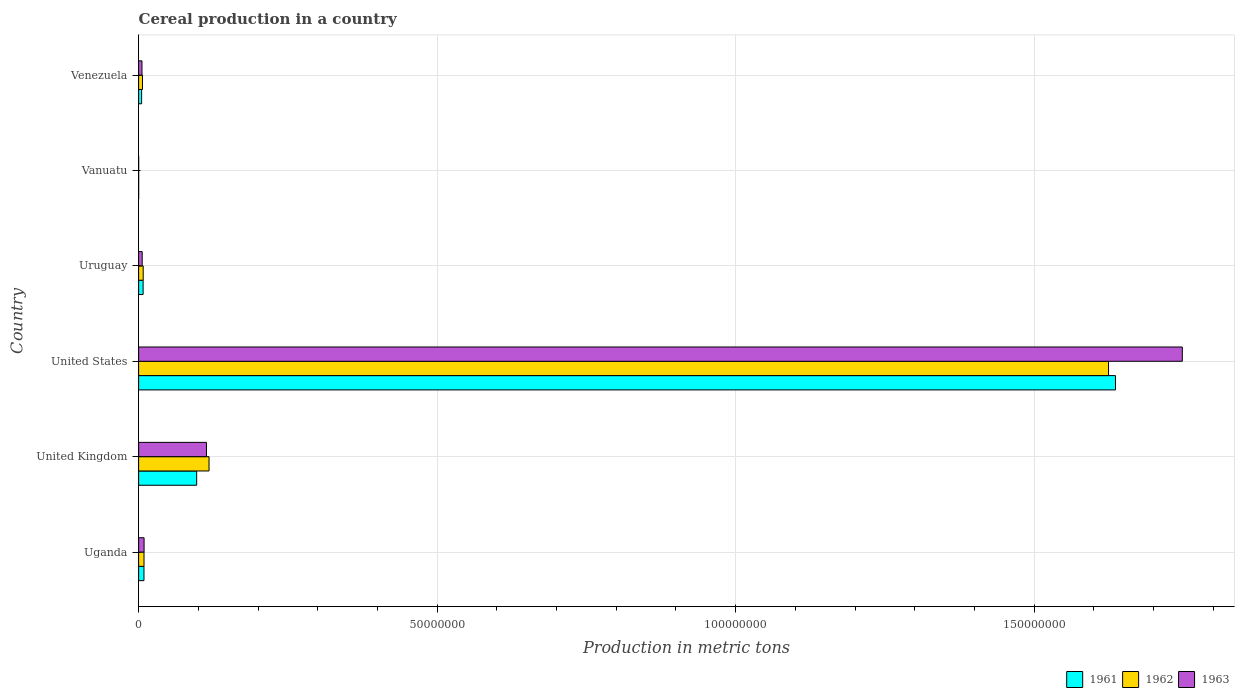How many different coloured bars are there?
Provide a short and direct response. 3. How many bars are there on the 5th tick from the top?
Offer a very short reply. 3. What is the label of the 3rd group of bars from the top?
Offer a terse response. Uruguay. What is the total cereal production in 1963 in Venezuela?
Offer a very short reply. 5.62e+05. Across all countries, what is the maximum total cereal production in 1962?
Your answer should be very brief. 1.62e+08. Across all countries, what is the minimum total cereal production in 1961?
Your response must be concise. 350. In which country was the total cereal production in 1961 maximum?
Keep it short and to the point. United States. In which country was the total cereal production in 1963 minimum?
Provide a succinct answer. Vanuatu. What is the total total cereal production in 1962 in the graph?
Ensure brevity in your answer.  1.77e+08. What is the difference between the total cereal production in 1961 in United States and that in Vanuatu?
Offer a terse response. 1.64e+08. What is the difference between the total cereal production in 1963 in Venezuela and the total cereal production in 1961 in United States?
Provide a succinct answer. -1.63e+08. What is the average total cereal production in 1961 per country?
Offer a very short reply. 2.92e+07. What is the difference between the total cereal production in 1962 and total cereal production in 1961 in Uruguay?
Keep it short and to the point. 1.37e+04. What is the ratio of the total cereal production in 1961 in Uganda to that in United States?
Your answer should be compact. 0.01. Is the total cereal production in 1963 in United Kingdom less than that in United States?
Your answer should be very brief. Yes. Is the difference between the total cereal production in 1962 in United States and Uruguay greater than the difference between the total cereal production in 1961 in United States and Uruguay?
Offer a terse response. No. What is the difference between the highest and the second highest total cereal production in 1962?
Provide a succinct answer. 1.51e+08. What is the difference between the highest and the lowest total cereal production in 1962?
Keep it short and to the point. 1.62e+08. In how many countries, is the total cereal production in 1963 greater than the average total cereal production in 1963 taken over all countries?
Make the answer very short. 1. Is the sum of the total cereal production in 1962 in United States and Uruguay greater than the maximum total cereal production in 1961 across all countries?
Provide a short and direct response. No. What does the 3rd bar from the top in Vanuatu represents?
Provide a succinct answer. 1961. Is it the case that in every country, the sum of the total cereal production in 1961 and total cereal production in 1963 is greater than the total cereal production in 1962?
Your answer should be very brief. Yes. How many countries are there in the graph?
Ensure brevity in your answer.  6. Where does the legend appear in the graph?
Offer a very short reply. Bottom right. How are the legend labels stacked?
Make the answer very short. Horizontal. What is the title of the graph?
Your response must be concise. Cereal production in a country. Does "1983" appear as one of the legend labels in the graph?
Provide a succinct answer. No. What is the label or title of the X-axis?
Provide a short and direct response. Production in metric tons. What is the Production in metric tons in 1961 in Uganda?
Your answer should be compact. 8.95e+05. What is the Production in metric tons of 1962 in Uganda?
Ensure brevity in your answer.  9.02e+05. What is the Production in metric tons of 1963 in Uganda?
Offer a terse response. 9.13e+05. What is the Production in metric tons of 1961 in United Kingdom?
Your answer should be compact. 9.72e+06. What is the Production in metric tons of 1962 in United Kingdom?
Offer a terse response. 1.18e+07. What is the Production in metric tons in 1963 in United Kingdom?
Your answer should be compact. 1.14e+07. What is the Production in metric tons of 1961 in United States?
Make the answer very short. 1.64e+08. What is the Production in metric tons in 1962 in United States?
Give a very brief answer. 1.62e+08. What is the Production in metric tons of 1963 in United States?
Ensure brevity in your answer.  1.75e+08. What is the Production in metric tons in 1961 in Uruguay?
Your answer should be compact. 7.51e+05. What is the Production in metric tons in 1962 in Uruguay?
Make the answer very short. 7.65e+05. What is the Production in metric tons in 1963 in Uruguay?
Provide a succinct answer. 5.97e+05. What is the Production in metric tons of 1961 in Vanuatu?
Give a very brief answer. 350. What is the Production in metric tons of 1962 in Vanuatu?
Make the answer very short. 350. What is the Production in metric tons in 1963 in Vanuatu?
Offer a terse response. 350. What is the Production in metric tons of 1961 in Venezuela?
Your response must be concise. 5.01e+05. What is the Production in metric tons of 1962 in Venezuela?
Provide a short and direct response. 6.44e+05. What is the Production in metric tons in 1963 in Venezuela?
Offer a terse response. 5.62e+05. Across all countries, what is the maximum Production in metric tons of 1961?
Your answer should be compact. 1.64e+08. Across all countries, what is the maximum Production in metric tons of 1962?
Keep it short and to the point. 1.62e+08. Across all countries, what is the maximum Production in metric tons of 1963?
Ensure brevity in your answer.  1.75e+08. Across all countries, what is the minimum Production in metric tons in 1961?
Your response must be concise. 350. Across all countries, what is the minimum Production in metric tons of 1962?
Ensure brevity in your answer.  350. Across all countries, what is the minimum Production in metric tons in 1963?
Offer a terse response. 350. What is the total Production in metric tons in 1961 in the graph?
Give a very brief answer. 1.75e+08. What is the total Production in metric tons of 1962 in the graph?
Your response must be concise. 1.77e+08. What is the total Production in metric tons of 1963 in the graph?
Offer a terse response. 1.88e+08. What is the difference between the Production in metric tons in 1961 in Uganda and that in United Kingdom?
Your answer should be very brief. -8.83e+06. What is the difference between the Production in metric tons in 1962 in Uganda and that in United Kingdom?
Your response must be concise. -1.09e+07. What is the difference between the Production in metric tons in 1963 in Uganda and that in United Kingdom?
Keep it short and to the point. -1.05e+07. What is the difference between the Production in metric tons of 1961 in Uganda and that in United States?
Your response must be concise. -1.63e+08. What is the difference between the Production in metric tons in 1962 in Uganda and that in United States?
Offer a very short reply. -1.62e+08. What is the difference between the Production in metric tons of 1963 in Uganda and that in United States?
Ensure brevity in your answer.  -1.74e+08. What is the difference between the Production in metric tons of 1961 in Uganda and that in Uruguay?
Provide a short and direct response. 1.44e+05. What is the difference between the Production in metric tons of 1962 in Uganda and that in Uruguay?
Offer a terse response. 1.37e+05. What is the difference between the Production in metric tons in 1963 in Uganda and that in Uruguay?
Make the answer very short. 3.16e+05. What is the difference between the Production in metric tons of 1961 in Uganda and that in Vanuatu?
Make the answer very short. 8.95e+05. What is the difference between the Production in metric tons of 1962 in Uganda and that in Vanuatu?
Your response must be concise. 9.02e+05. What is the difference between the Production in metric tons in 1963 in Uganda and that in Vanuatu?
Your answer should be compact. 9.12e+05. What is the difference between the Production in metric tons in 1961 in Uganda and that in Venezuela?
Offer a very short reply. 3.94e+05. What is the difference between the Production in metric tons of 1962 in Uganda and that in Venezuela?
Keep it short and to the point. 2.58e+05. What is the difference between the Production in metric tons of 1963 in Uganda and that in Venezuela?
Ensure brevity in your answer.  3.50e+05. What is the difference between the Production in metric tons of 1961 in United Kingdom and that in United States?
Provide a short and direct response. -1.54e+08. What is the difference between the Production in metric tons in 1962 in United Kingdom and that in United States?
Provide a succinct answer. -1.51e+08. What is the difference between the Production in metric tons of 1963 in United Kingdom and that in United States?
Make the answer very short. -1.63e+08. What is the difference between the Production in metric tons in 1961 in United Kingdom and that in Uruguay?
Provide a short and direct response. 8.97e+06. What is the difference between the Production in metric tons in 1962 in United Kingdom and that in Uruguay?
Provide a short and direct response. 1.10e+07. What is the difference between the Production in metric tons of 1963 in United Kingdom and that in Uruguay?
Provide a short and direct response. 1.08e+07. What is the difference between the Production in metric tons of 1961 in United Kingdom and that in Vanuatu?
Make the answer very short. 9.72e+06. What is the difference between the Production in metric tons of 1962 in United Kingdom and that in Vanuatu?
Give a very brief answer. 1.18e+07. What is the difference between the Production in metric tons in 1963 in United Kingdom and that in Vanuatu?
Offer a terse response. 1.14e+07. What is the difference between the Production in metric tons of 1961 in United Kingdom and that in Venezuela?
Give a very brief answer. 9.22e+06. What is the difference between the Production in metric tons in 1962 in United Kingdom and that in Venezuela?
Ensure brevity in your answer.  1.11e+07. What is the difference between the Production in metric tons of 1963 in United Kingdom and that in Venezuela?
Provide a succinct answer. 1.08e+07. What is the difference between the Production in metric tons of 1961 in United States and that in Uruguay?
Provide a succinct answer. 1.63e+08. What is the difference between the Production in metric tons of 1962 in United States and that in Uruguay?
Provide a succinct answer. 1.62e+08. What is the difference between the Production in metric tons of 1963 in United States and that in Uruguay?
Give a very brief answer. 1.74e+08. What is the difference between the Production in metric tons in 1961 in United States and that in Vanuatu?
Provide a short and direct response. 1.64e+08. What is the difference between the Production in metric tons of 1962 in United States and that in Vanuatu?
Provide a succinct answer. 1.62e+08. What is the difference between the Production in metric tons in 1963 in United States and that in Vanuatu?
Your response must be concise. 1.75e+08. What is the difference between the Production in metric tons of 1961 in United States and that in Venezuela?
Provide a short and direct response. 1.63e+08. What is the difference between the Production in metric tons in 1962 in United States and that in Venezuela?
Make the answer very short. 1.62e+08. What is the difference between the Production in metric tons in 1963 in United States and that in Venezuela?
Offer a terse response. 1.74e+08. What is the difference between the Production in metric tons in 1961 in Uruguay and that in Vanuatu?
Ensure brevity in your answer.  7.51e+05. What is the difference between the Production in metric tons in 1962 in Uruguay and that in Vanuatu?
Offer a terse response. 7.64e+05. What is the difference between the Production in metric tons of 1963 in Uruguay and that in Vanuatu?
Ensure brevity in your answer.  5.96e+05. What is the difference between the Production in metric tons of 1961 in Uruguay and that in Venezuela?
Offer a terse response. 2.50e+05. What is the difference between the Production in metric tons in 1962 in Uruguay and that in Venezuela?
Your response must be concise. 1.20e+05. What is the difference between the Production in metric tons in 1963 in Uruguay and that in Venezuela?
Make the answer very short. 3.44e+04. What is the difference between the Production in metric tons in 1961 in Vanuatu and that in Venezuela?
Your answer should be compact. -5.01e+05. What is the difference between the Production in metric tons in 1962 in Vanuatu and that in Venezuela?
Make the answer very short. -6.44e+05. What is the difference between the Production in metric tons of 1963 in Vanuatu and that in Venezuela?
Offer a terse response. -5.62e+05. What is the difference between the Production in metric tons of 1961 in Uganda and the Production in metric tons of 1962 in United Kingdom?
Offer a very short reply. -1.09e+07. What is the difference between the Production in metric tons in 1961 in Uganda and the Production in metric tons in 1963 in United Kingdom?
Ensure brevity in your answer.  -1.05e+07. What is the difference between the Production in metric tons in 1962 in Uganda and the Production in metric tons in 1963 in United Kingdom?
Your answer should be compact. -1.05e+07. What is the difference between the Production in metric tons of 1961 in Uganda and the Production in metric tons of 1962 in United States?
Offer a terse response. -1.62e+08. What is the difference between the Production in metric tons of 1961 in Uganda and the Production in metric tons of 1963 in United States?
Your answer should be compact. -1.74e+08. What is the difference between the Production in metric tons in 1962 in Uganda and the Production in metric tons in 1963 in United States?
Offer a terse response. -1.74e+08. What is the difference between the Production in metric tons in 1961 in Uganda and the Production in metric tons in 1962 in Uruguay?
Your response must be concise. 1.31e+05. What is the difference between the Production in metric tons of 1961 in Uganda and the Production in metric tons of 1963 in Uruguay?
Offer a very short reply. 2.98e+05. What is the difference between the Production in metric tons in 1962 in Uganda and the Production in metric tons in 1963 in Uruguay?
Your answer should be compact. 3.05e+05. What is the difference between the Production in metric tons in 1961 in Uganda and the Production in metric tons in 1962 in Vanuatu?
Make the answer very short. 8.95e+05. What is the difference between the Production in metric tons in 1961 in Uganda and the Production in metric tons in 1963 in Vanuatu?
Your answer should be very brief. 8.95e+05. What is the difference between the Production in metric tons of 1962 in Uganda and the Production in metric tons of 1963 in Vanuatu?
Keep it short and to the point. 9.02e+05. What is the difference between the Production in metric tons in 1961 in Uganda and the Production in metric tons in 1962 in Venezuela?
Keep it short and to the point. 2.51e+05. What is the difference between the Production in metric tons in 1961 in Uganda and the Production in metric tons in 1963 in Venezuela?
Your response must be concise. 3.33e+05. What is the difference between the Production in metric tons in 1962 in Uganda and the Production in metric tons in 1963 in Venezuela?
Provide a short and direct response. 3.40e+05. What is the difference between the Production in metric tons in 1961 in United Kingdom and the Production in metric tons in 1962 in United States?
Give a very brief answer. -1.53e+08. What is the difference between the Production in metric tons in 1961 in United Kingdom and the Production in metric tons in 1963 in United States?
Provide a short and direct response. -1.65e+08. What is the difference between the Production in metric tons of 1962 in United Kingdom and the Production in metric tons of 1963 in United States?
Your response must be concise. -1.63e+08. What is the difference between the Production in metric tons of 1961 in United Kingdom and the Production in metric tons of 1962 in Uruguay?
Offer a terse response. 8.96e+06. What is the difference between the Production in metric tons of 1961 in United Kingdom and the Production in metric tons of 1963 in Uruguay?
Provide a short and direct response. 9.13e+06. What is the difference between the Production in metric tons in 1962 in United Kingdom and the Production in metric tons in 1963 in Uruguay?
Make the answer very short. 1.12e+07. What is the difference between the Production in metric tons in 1961 in United Kingdom and the Production in metric tons in 1962 in Vanuatu?
Make the answer very short. 9.72e+06. What is the difference between the Production in metric tons of 1961 in United Kingdom and the Production in metric tons of 1963 in Vanuatu?
Offer a very short reply. 9.72e+06. What is the difference between the Production in metric tons in 1962 in United Kingdom and the Production in metric tons in 1963 in Vanuatu?
Your answer should be compact. 1.18e+07. What is the difference between the Production in metric tons of 1961 in United Kingdom and the Production in metric tons of 1962 in Venezuela?
Provide a succinct answer. 9.08e+06. What is the difference between the Production in metric tons in 1961 in United Kingdom and the Production in metric tons in 1963 in Venezuela?
Make the answer very short. 9.16e+06. What is the difference between the Production in metric tons in 1962 in United Kingdom and the Production in metric tons in 1963 in Venezuela?
Keep it short and to the point. 1.12e+07. What is the difference between the Production in metric tons in 1961 in United States and the Production in metric tons in 1962 in Uruguay?
Your answer should be compact. 1.63e+08. What is the difference between the Production in metric tons of 1961 in United States and the Production in metric tons of 1963 in Uruguay?
Your response must be concise. 1.63e+08. What is the difference between the Production in metric tons of 1962 in United States and the Production in metric tons of 1963 in Uruguay?
Offer a very short reply. 1.62e+08. What is the difference between the Production in metric tons of 1961 in United States and the Production in metric tons of 1962 in Vanuatu?
Your response must be concise. 1.64e+08. What is the difference between the Production in metric tons in 1961 in United States and the Production in metric tons in 1963 in Vanuatu?
Ensure brevity in your answer.  1.64e+08. What is the difference between the Production in metric tons in 1962 in United States and the Production in metric tons in 1963 in Vanuatu?
Offer a very short reply. 1.62e+08. What is the difference between the Production in metric tons of 1961 in United States and the Production in metric tons of 1962 in Venezuela?
Ensure brevity in your answer.  1.63e+08. What is the difference between the Production in metric tons of 1961 in United States and the Production in metric tons of 1963 in Venezuela?
Ensure brevity in your answer.  1.63e+08. What is the difference between the Production in metric tons of 1962 in United States and the Production in metric tons of 1963 in Venezuela?
Offer a terse response. 1.62e+08. What is the difference between the Production in metric tons of 1961 in Uruguay and the Production in metric tons of 1962 in Vanuatu?
Offer a terse response. 7.51e+05. What is the difference between the Production in metric tons in 1961 in Uruguay and the Production in metric tons in 1963 in Vanuatu?
Make the answer very short. 7.51e+05. What is the difference between the Production in metric tons in 1962 in Uruguay and the Production in metric tons in 1963 in Vanuatu?
Offer a very short reply. 7.64e+05. What is the difference between the Production in metric tons of 1961 in Uruguay and the Production in metric tons of 1962 in Venezuela?
Ensure brevity in your answer.  1.07e+05. What is the difference between the Production in metric tons in 1961 in Uruguay and the Production in metric tons in 1963 in Venezuela?
Your response must be concise. 1.89e+05. What is the difference between the Production in metric tons of 1962 in Uruguay and the Production in metric tons of 1963 in Venezuela?
Offer a terse response. 2.02e+05. What is the difference between the Production in metric tons of 1961 in Vanuatu and the Production in metric tons of 1962 in Venezuela?
Offer a very short reply. -6.44e+05. What is the difference between the Production in metric tons of 1961 in Vanuatu and the Production in metric tons of 1963 in Venezuela?
Your answer should be compact. -5.62e+05. What is the difference between the Production in metric tons of 1962 in Vanuatu and the Production in metric tons of 1963 in Venezuela?
Offer a very short reply. -5.62e+05. What is the average Production in metric tons of 1961 per country?
Your answer should be compact. 2.92e+07. What is the average Production in metric tons of 1962 per country?
Your answer should be compact. 2.94e+07. What is the average Production in metric tons of 1963 per country?
Your answer should be very brief. 3.14e+07. What is the difference between the Production in metric tons of 1961 and Production in metric tons of 1962 in Uganda?
Offer a terse response. -6800. What is the difference between the Production in metric tons in 1961 and Production in metric tons in 1963 in Uganda?
Provide a succinct answer. -1.74e+04. What is the difference between the Production in metric tons in 1962 and Production in metric tons in 1963 in Uganda?
Provide a succinct answer. -1.06e+04. What is the difference between the Production in metric tons of 1961 and Production in metric tons of 1962 in United Kingdom?
Offer a terse response. -2.07e+06. What is the difference between the Production in metric tons in 1961 and Production in metric tons in 1963 in United Kingdom?
Your answer should be compact. -1.64e+06. What is the difference between the Production in metric tons of 1962 and Production in metric tons of 1963 in United Kingdom?
Keep it short and to the point. 4.26e+05. What is the difference between the Production in metric tons in 1961 and Production in metric tons in 1962 in United States?
Offer a terse response. 1.16e+06. What is the difference between the Production in metric tons of 1961 and Production in metric tons of 1963 in United States?
Your answer should be compact. -1.12e+07. What is the difference between the Production in metric tons of 1962 and Production in metric tons of 1963 in United States?
Provide a short and direct response. -1.24e+07. What is the difference between the Production in metric tons in 1961 and Production in metric tons in 1962 in Uruguay?
Your answer should be very brief. -1.37e+04. What is the difference between the Production in metric tons of 1961 and Production in metric tons of 1963 in Uruguay?
Make the answer very short. 1.54e+05. What is the difference between the Production in metric tons in 1962 and Production in metric tons in 1963 in Uruguay?
Your answer should be compact. 1.68e+05. What is the difference between the Production in metric tons of 1961 and Production in metric tons of 1962 in Venezuela?
Your answer should be compact. -1.43e+05. What is the difference between the Production in metric tons of 1961 and Production in metric tons of 1963 in Venezuela?
Give a very brief answer. -6.10e+04. What is the difference between the Production in metric tons in 1962 and Production in metric tons in 1963 in Venezuela?
Ensure brevity in your answer.  8.18e+04. What is the ratio of the Production in metric tons of 1961 in Uganda to that in United Kingdom?
Your answer should be compact. 0.09. What is the ratio of the Production in metric tons in 1962 in Uganda to that in United Kingdom?
Provide a succinct answer. 0.08. What is the ratio of the Production in metric tons in 1963 in Uganda to that in United Kingdom?
Ensure brevity in your answer.  0.08. What is the ratio of the Production in metric tons in 1961 in Uganda to that in United States?
Offer a very short reply. 0.01. What is the ratio of the Production in metric tons in 1962 in Uganda to that in United States?
Keep it short and to the point. 0.01. What is the ratio of the Production in metric tons of 1963 in Uganda to that in United States?
Make the answer very short. 0.01. What is the ratio of the Production in metric tons of 1961 in Uganda to that in Uruguay?
Your response must be concise. 1.19. What is the ratio of the Production in metric tons in 1962 in Uganda to that in Uruguay?
Provide a succinct answer. 1.18. What is the ratio of the Production in metric tons in 1963 in Uganda to that in Uruguay?
Provide a short and direct response. 1.53. What is the ratio of the Production in metric tons of 1961 in Uganda to that in Vanuatu?
Keep it short and to the point. 2557.71. What is the ratio of the Production in metric tons of 1962 in Uganda to that in Vanuatu?
Ensure brevity in your answer.  2577.14. What is the ratio of the Production in metric tons in 1963 in Uganda to that in Vanuatu?
Offer a terse response. 2607.57. What is the ratio of the Production in metric tons in 1961 in Uganda to that in Venezuela?
Your response must be concise. 1.79. What is the ratio of the Production in metric tons of 1962 in Uganda to that in Venezuela?
Offer a terse response. 1.4. What is the ratio of the Production in metric tons of 1963 in Uganda to that in Venezuela?
Your answer should be compact. 1.62. What is the ratio of the Production in metric tons in 1961 in United Kingdom to that in United States?
Ensure brevity in your answer.  0.06. What is the ratio of the Production in metric tons of 1962 in United Kingdom to that in United States?
Keep it short and to the point. 0.07. What is the ratio of the Production in metric tons of 1963 in United Kingdom to that in United States?
Provide a succinct answer. 0.07. What is the ratio of the Production in metric tons of 1961 in United Kingdom to that in Uruguay?
Your answer should be compact. 12.95. What is the ratio of the Production in metric tons of 1962 in United Kingdom to that in Uruguay?
Your answer should be very brief. 15.42. What is the ratio of the Production in metric tons of 1963 in United Kingdom to that in Uruguay?
Your answer should be compact. 19.04. What is the ratio of the Production in metric tons of 1961 in United Kingdom to that in Vanuatu?
Keep it short and to the point. 2.78e+04. What is the ratio of the Production in metric tons in 1962 in United Kingdom to that in Vanuatu?
Your response must be concise. 3.37e+04. What is the ratio of the Production in metric tons in 1963 in United Kingdom to that in Vanuatu?
Give a very brief answer. 3.25e+04. What is the ratio of the Production in metric tons of 1961 in United Kingdom to that in Venezuela?
Provide a short and direct response. 19.39. What is the ratio of the Production in metric tons in 1962 in United Kingdom to that in Venezuela?
Make the answer very short. 18.3. What is the ratio of the Production in metric tons of 1963 in United Kingdom to that in Venezuela?
Offer a very short reply. 20.21. What is the ratio of the Production in metric tons in 1961 in United States to that in Uruguay?
Your response must be concise. 217.89. What is the ratio of the Production in metric tons of 1962 in United States to that in Uruguay?
Make the answer very short. 212.46. What is the ratio of the Production in metric tons of 1963 in United States to that in Uruguay?
Keep it short and to the point. 292.92. What is the ratio of the Production in metric tons of 1961 in United States to that in Vanuatu?
Your answer should be very brief. 4.67e+05. What is the ratio of the Production in metric tons of 1962 in United States to that in Vanuatu?
Offer a terse response. 4.64e+05. What is the ratio of the Production in metric tons in 1963 in United States to that in Vanuatu?
Your answer should be very brief. 4.99e+05. What is the ratio of the Production in metric tons of 1961 in United States to that in Venezuela?
Provide a short and direct response. 326.33. What is the ratio of the Production in metric tons of 1962 in United States to that in Venezuela?
Provide a succinct answer. 252.17. What is the ratio of the Production in metric tons in 1963 in United States to that in Venezuela?
Give a very brief answer. 310.84. What is the ratio of the Production in metric tons in 1961 in Uruguay to that in Vanuatu?
Offer a terse response. 2145.5. What is the ratio of the Production in metric tons in 1962 in Uruguay to that in Vanuatu?
Your response must be concise. 2184.7. What is the ratio of the Production in metric tons of 1963 in Uruguay to that in Vanuatu?
Offer a terse response. 1705.1. What is the ratio of the Production in metric tons of 1961 in Uruguay to that in Venezuela?
Provide a succinct answer. 1.5. What is the ratio of the Production in metric tons of 1962 in Uruguay to that in Venezuela?
Ensure brevity in your answer.  1.19. What is the ratio of the Production in metric tons in 1963 in Uruguay to that in Venezuela?
Provide a short and direct response. 1.06. What is the ratio of the Production in metric tons in 1961 in Vanuatu to that in Venezuela?
Provide a succinct answer. 0. What is the ratio of the Production in metric tons in 1962 in Vanuatu to that in Venezuela?
Provide a succinct answer. 0. What is the ratio of the Production in metric tons of 1963 in Vanuatu to that in Venezuela?
Provide a succinct answer. 0. What is the difference between the highest and the second highest Production in metric tons of 1961?
Make the answer very short. 1.54e+08. What is the difference between the highest and the second highest Production in metric tons of 1962?
Your response must be concise. 1.51e+08. What is the difference between the highest and the second highest Production in metric tons in 1963?
Offer a terse response. 1.63e+08. What is the difference between the highest and the lowest Production in metric tons in 1961?
Offer a very short reply. 1.64e+08. What is the difference between the highest and the lowest Production in metric tons in 1962?
Your answer should be very brief. 1.62e+08. What is the difference between the highest and the lowest Production in metric tons of 1963?
Keep it short and to the point. 1.75e+08. 